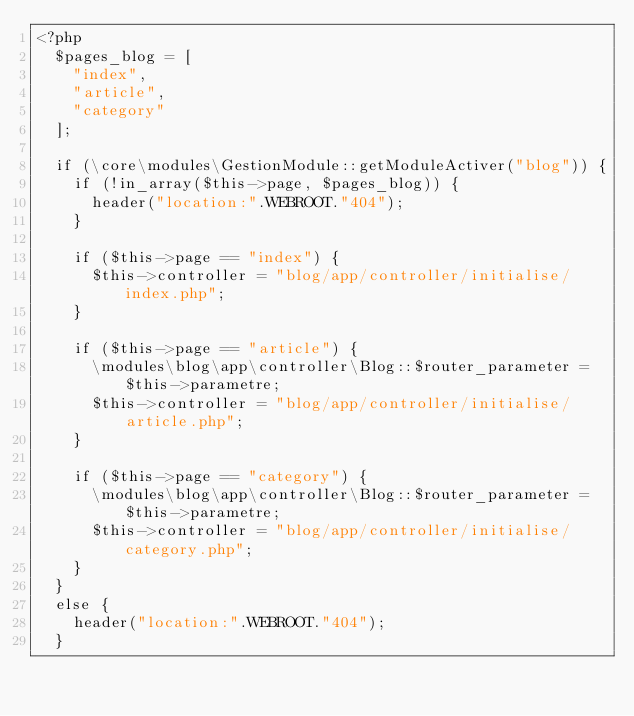Convert code to text. <code><loc_0><loc_0><loc_500><loc_500><_PHP_><?php
	$pages_blog = [
		"index",
		"article",
		"category"
	];
	
	if (\core\modules\GestionModule::getModuleActiver("blog")) {
		if (!in_array($this->page, $pages_blog)) {
			header("location:".WEBROOT."404");
		}
		
		if ($this->page == "index") {
			$this->controller = "blog/app/controller/initialise/index.php";
		}
		
		if ($this->page == "article") {
			\modules\blog\app\controller\Blog::$router_parameter = $this->parametre;
			$this->controller = "blog/app/controller/initialise/article.php";
		}
		
		if ($this->page == "category") {
			\modules\blog\app\controller\Blog::$router_parameter = $this->parametre;
			$this->controller = "blog/app/controller/initialise/category.php";
		}
	}
	else {
		header("location:".WEBROOT."404");
	}</code> 